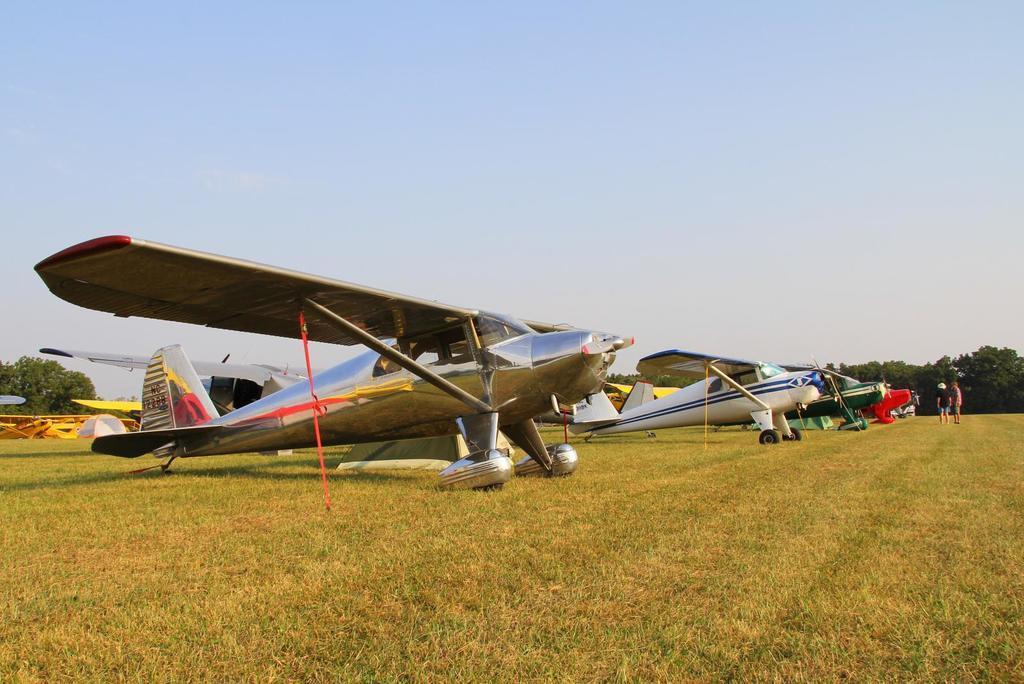Describe this image in one or two sentences. There are many aircraft on the grass. In the back there are trees and some people are there. In the background there is sky. 